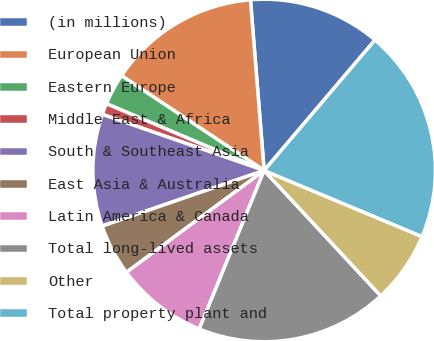Convert chart to OTSL. <chart><loc_0><loc_0><loc_500><loc_500><pie_chart><fcel>(in millions)<fcel>European Union<fcel>Eastern Europe<fcel>Middle East & Africa<fcel>South & Southeast Asia<fcel>East Asia & Australia<fcel>Latin America & Canada<fcel>Total long-lived assets<fcel>Other<fcel>Total property plant and<nl><fcel>12.48%<fcel>14.39%<fcel>2.96%<fcel>1.06%<fcel>10.58%<fcel>4.87%<fcel>8.68%<fcel>18.11%<fcel>6.77%<fcel>20.1%<nl></chart> 